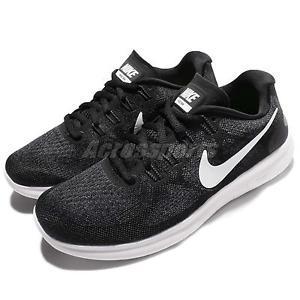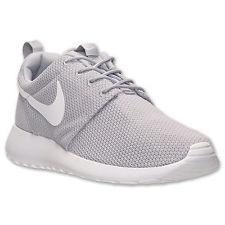The first image is the image on the left, the second image is the image on the right. Assess this claim about the two images: "There are exactly two shoes shown in one of the images.". Correct or not? Answer yes or no. Yes. 